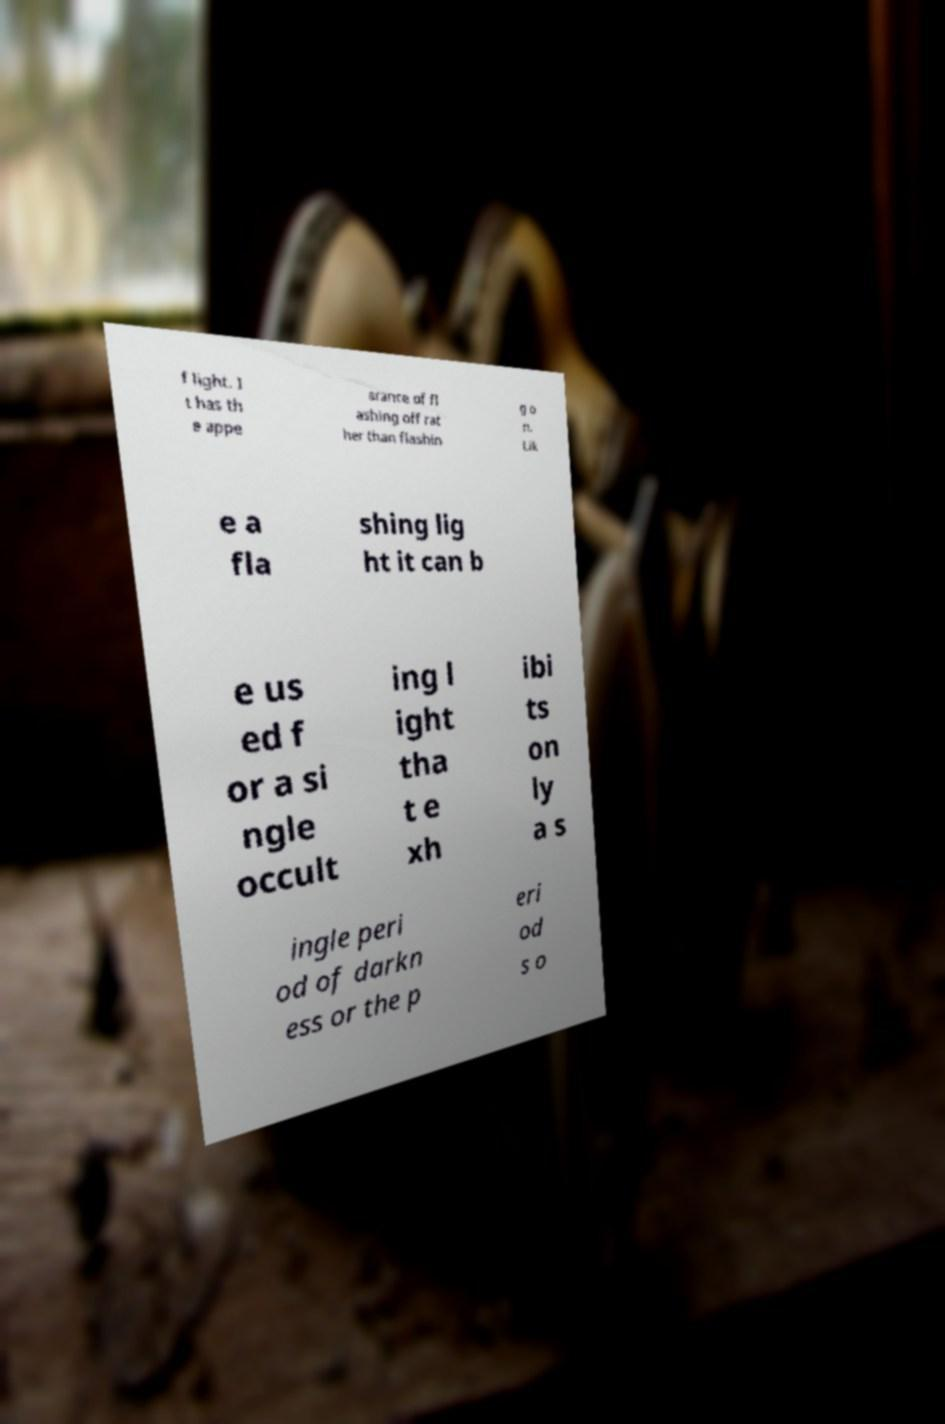Can you read and provide the text displayed in the image?This photo seems to have some interesting text. Can you extract and type it out for me? f light. I t has th e appe arance of fl ashing off rat her than flashin g o n. Lik e a fla shing lig ht it can b e us ed f or a si ngle occult ing l ight tha t e xh ibi ts on ly a s ingle peri od of darkn ess or the p eri od s o 